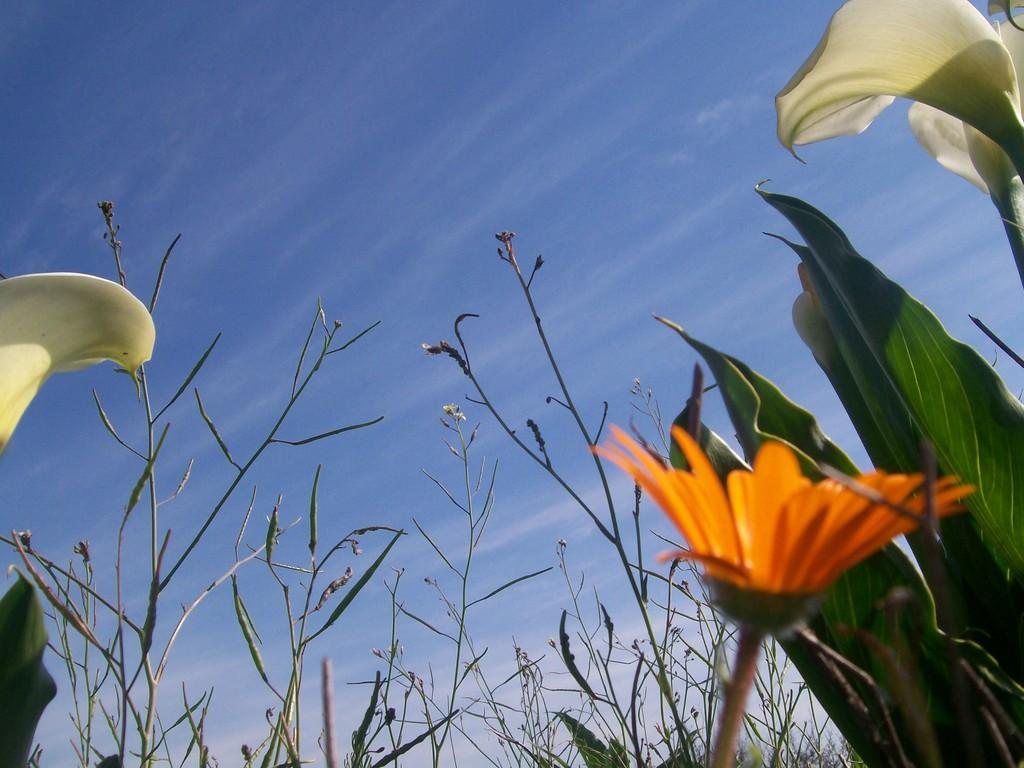What is the setting of the image? The image has an outside view. What can be seen in the foreground of the image? There are plants in the foreground of the image. Can you describe the flower in the image? There is a flower in the bottom right of the image. What is visible in the background of the image? There is a sky visible in the background of the image. How does the bridge connect the two sides of the image? There is no bridge present in the image; it features an outside view with plants in the foreground, a flower in the bottom right, and a sky in the background. 